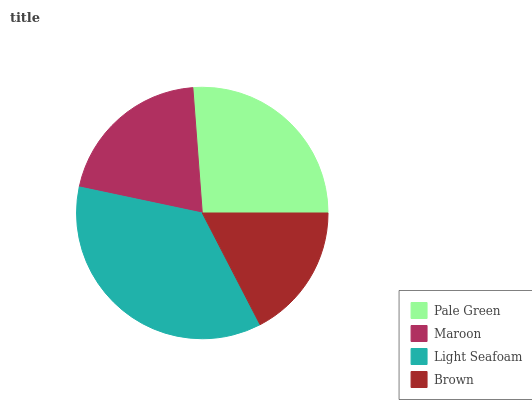Is Brown the minimum?
Answer yes or no. Yes. Is Light Seafoam the maximum?
Answer yes or no. Yes. Is Maroon the minimum?
Answer yes or no. No. Is Maroon the maximum?
Answer yes or no. No. Is Pale Green greater than Maroon?
Answer yes or no. Yes. Is Maroon less than Pale Green?
Answer yes or no. Yes. Is Maroon greater than Pale Green?
Answer yes or no. No. Is Pale Green less than Maroon?
Answer yes or no. No. Is Pale Green the high median?
Answer yes or no. Yes. Is Maroon the low median?
Answer yes or no. Yes. Is Brown the high median?
Answer yes or no. No. Is Pale Green the low median?
Answer yes or no. No. 